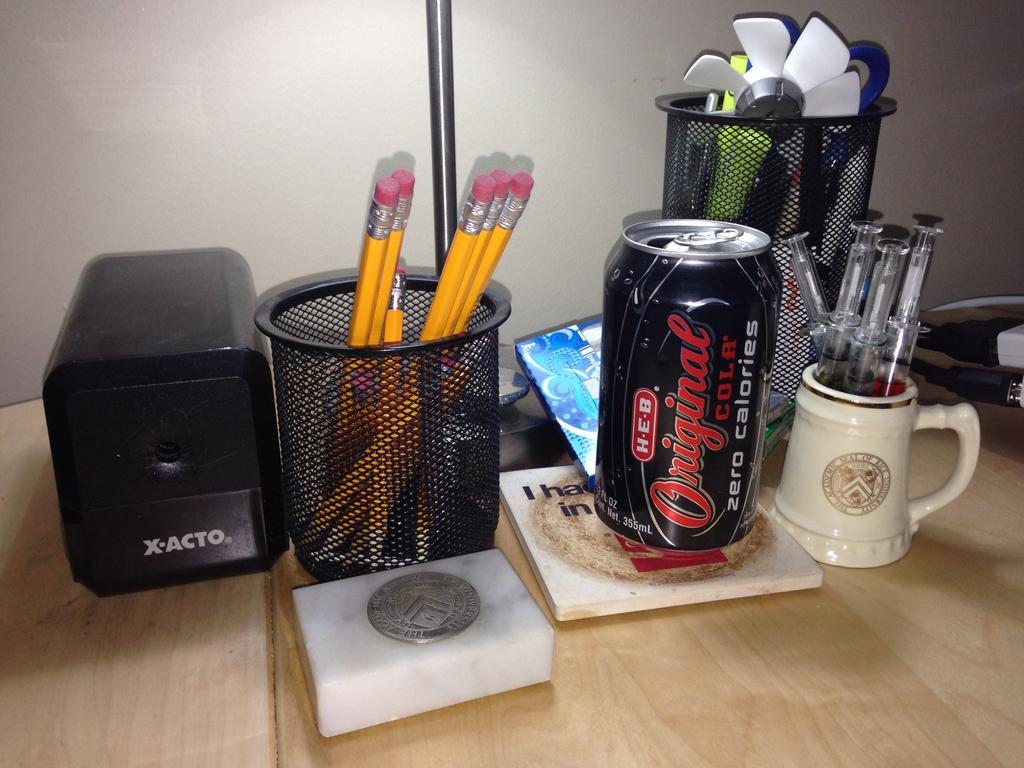Provide a one-sentence caption for the provided image. Black Original Cola can in between some pencils and syringes. 